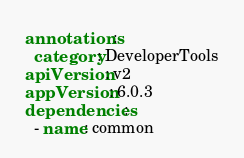<code> <loc_0><loc_0><loc_500><loc_500><_YAML_>annotations:
  category: DeveloperTools
apiVersion: v2
appVersion: 6.0.3
dependencies:
  - name: common</code> 